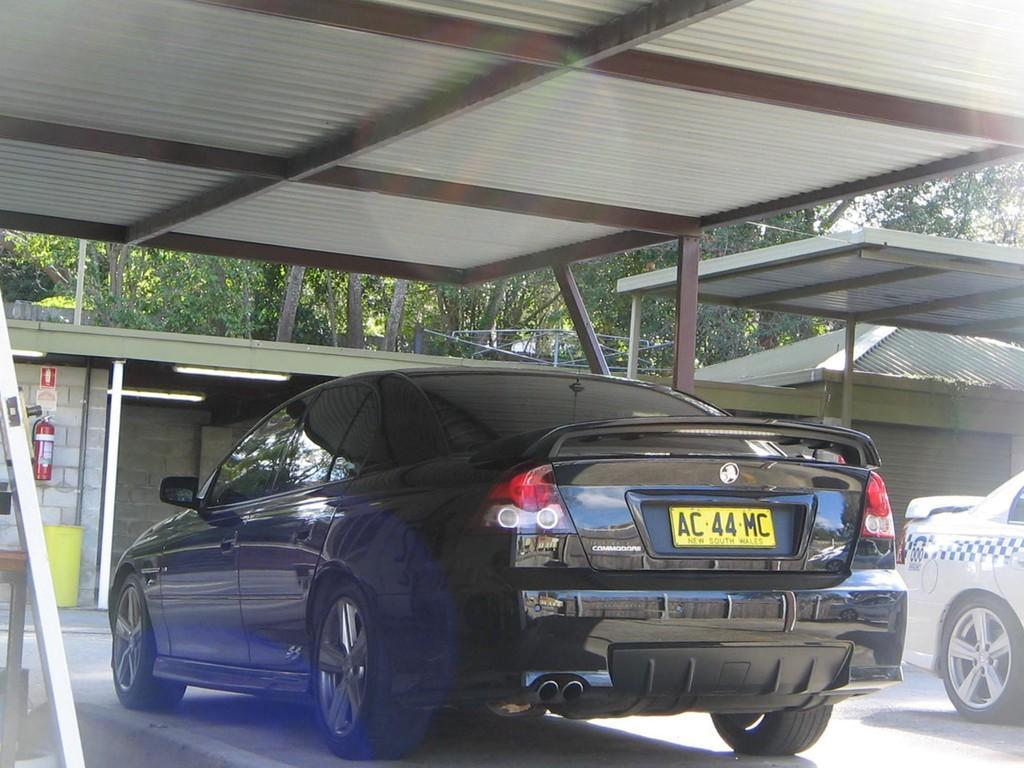Please provide a concise description of this image. In the foreground it is looking like there is a glass. On the left we can see a white color object and a wooden object. In the middle there are cars. At the top we can see iron roof. In the background there are buildings, trees, light and brick wall. On the left we can see fire extinguisher and dustbin. 